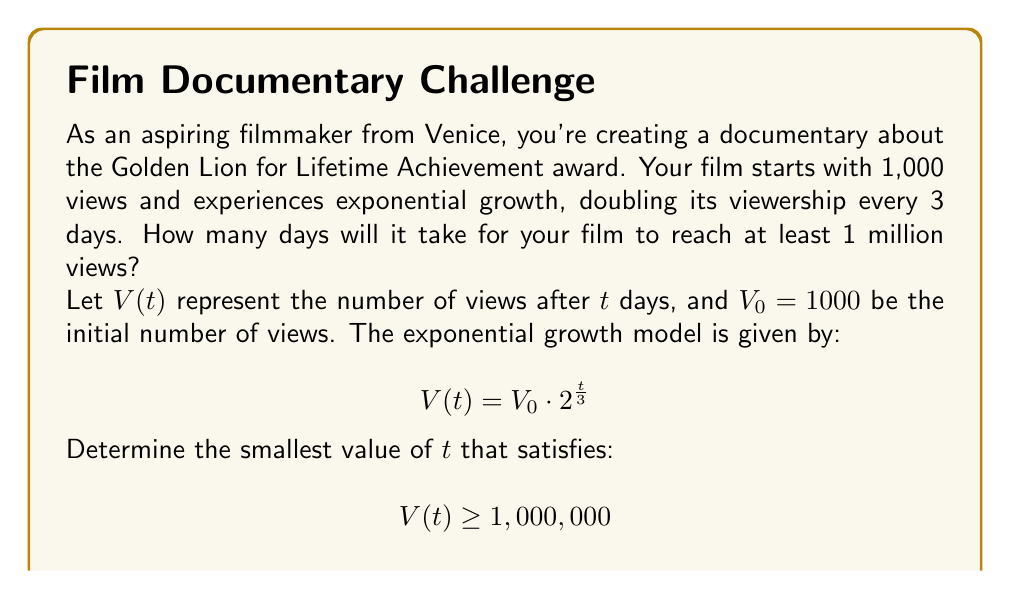Could you help me with this problem? To solve this problem, we'll follow these steps:

1) Start with the exponential growth equation:
   $$V(t) = V_0 \cdot 2^{\frac{t}{3}}$$

2) Substitute the known values:
   $$1,000,000 \leq 1000 \cdot 2^{\frac{t}{3}}$$

3) Divide both sides by 1000:
   $$1000 \leq 2^{\frac{t}{3}}$$

4) Take the logarithm (base 2) of both sides:
   $$\log_2(1000) \leq \frac{t}{3}$$

5) Multiply both sides by 3:
   $$3\log_2(1000) \leq t$$

6) Calculate the value:
   $$3 \cdot \frac{\log(1000)}{\log(2)} \approx 29.897$$

7) Since $t$ must be a whole number of days, we round up to the nearest integer:
   $$t = \lceil 29.897 \rceil = 30$$

Therefore, it will take 30 days for the film to reach at least 1 million views.

To verify:
$$V(30) = 1000 \cdot 2^{\frac{30}{3}} = 1000 \cdot 2^{10} = 1,024,000 > 1,000,000$$
Answer: 30 days 